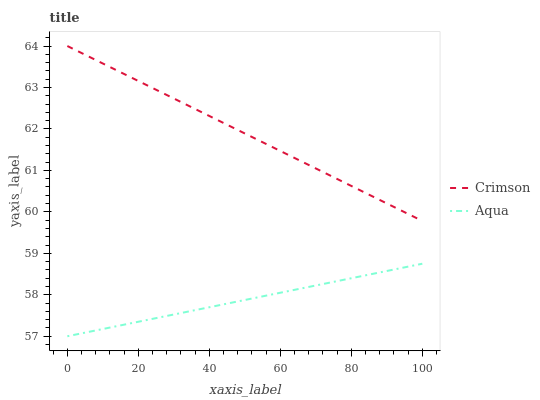Does Aqua have the maximum area under the curve?
Answer yes or no. No. Is Aqua the roughest?
Answer yes or no. No. Does Aqua have the highest value?
Answer yes or no. No. Is Aqua less than Crimson?
Answer yes or no. Yes. Is Crimson greater than Aqua?
Answer yes or no. Yes. Does Aqua intersect Crimson?
Answer yes or no. No. 